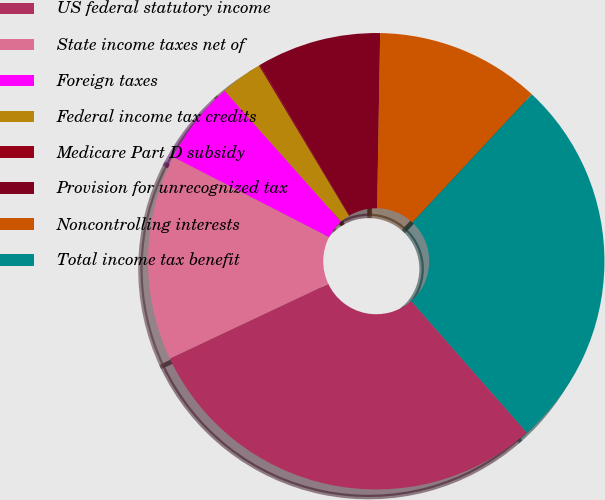<chart> <loc_0><loc_0><loc_500><loc_500><pie_chart><fcel>US federal statutory income<fcel>State income taxes net of<fcel>Foreign taxes<fcel>Federal income tax credits<fcel>Medicare Part D subsidy<fcel>Provision for unrecognized tax<fcel>Noncontrolling interests<fcel>Total income tax benefit<nl><fcel>29.47%<fcel>14.56%<fcel>5.88%<fcel>2.98%<fcel>0.09%<fcel>8.77%<fcel>11.67%<fcel>26.58%<nl></chart> 